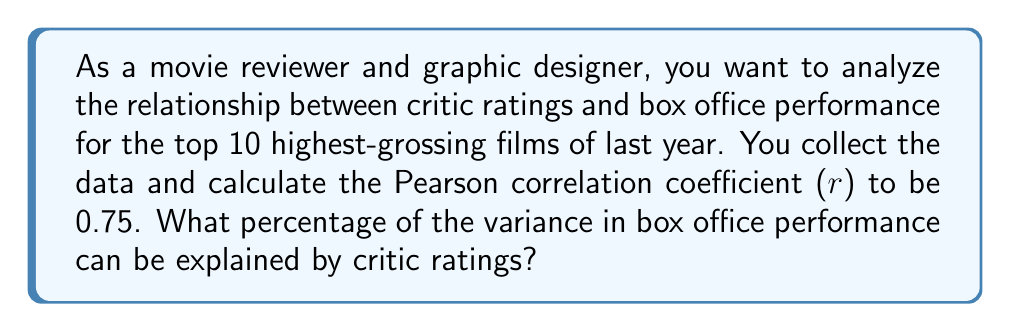Could you help me with this problem? To solve this problem, we need to understand the concept of the coefficient of determination, which is derived from the Pearson correlation coefficient.

1. The Pearson correlation coefficient (r) measures the strength and direction of the linear relationship between two variables. It ranges from -1 to 1.

2. The coefficient of determination, denoted as $R^2$, represents the proportion of variance in the dependent variable (in this case, box office performance) that is predictable from the independent variable (critic ratings).

3. The relationship between the Pearson correlation coefficient (r) and the coefficient of determination ($R^2$) is:

   $$R^2 = r^2$$

4. Given that r = 0.75, we can calculate $R^2$:

   $$R^2 = (0.75)^2 = 0.5625$$

5. To express this as a percentage, we multiply by 100:

   $$0.5625 \times 100 = 56.25\%$$

This means that 56.25% of the variance in box office performance can be explained by critic ratings.
Answer: 56.25% 